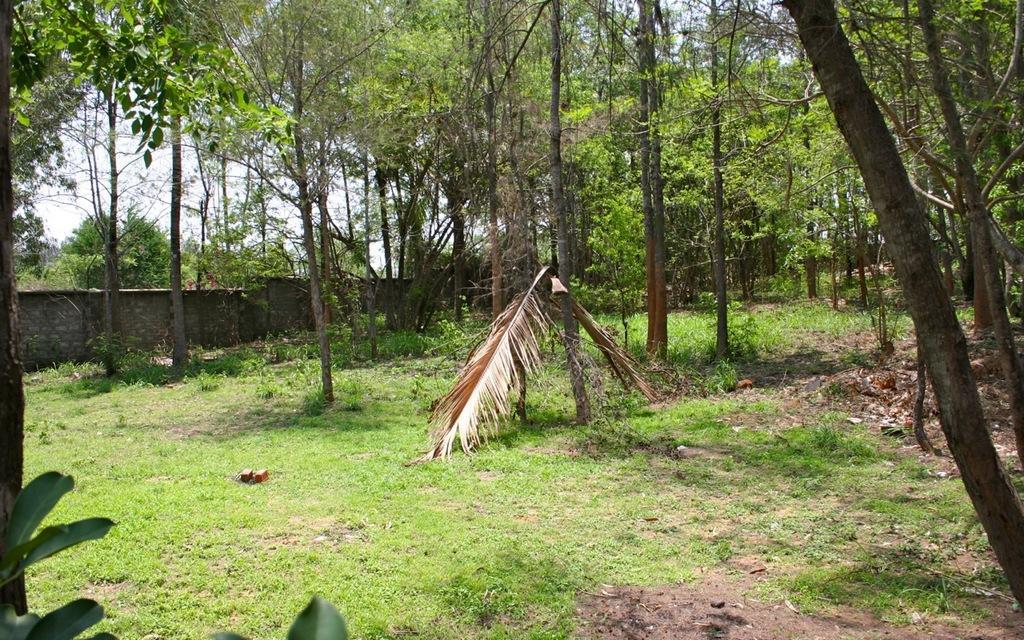How would you summarize this image in a sentence or two? Land is covered with grass. Here we can see a wall and trees. 